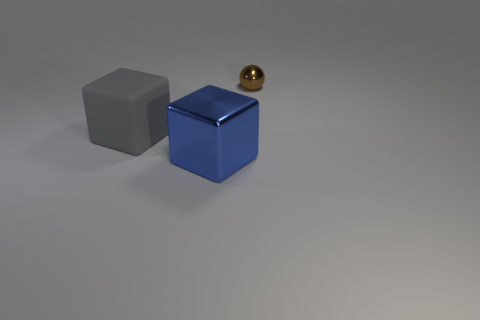Add 3 metallic objects. How many objects exist? 6 Add 3 blue shiny blocks. How many blue shiny blocks are left? 4 Add 2 tiny metal things. How many tiny metal things exist? 3 Subtract 1 brown balls. How many objects are left? 2 Subtract all cubes. How many objects are left? 1 Subtract 1 blocks. How many blocks are left? 1 Subtract all yellow spheres. Subtract all yellow cylinders. How many spheres are left? 1 Subtract all blue balls. How many blue blocks are left? 1 Subtract all big spheres. Subtract all blue objects. How many objects are left? 2 